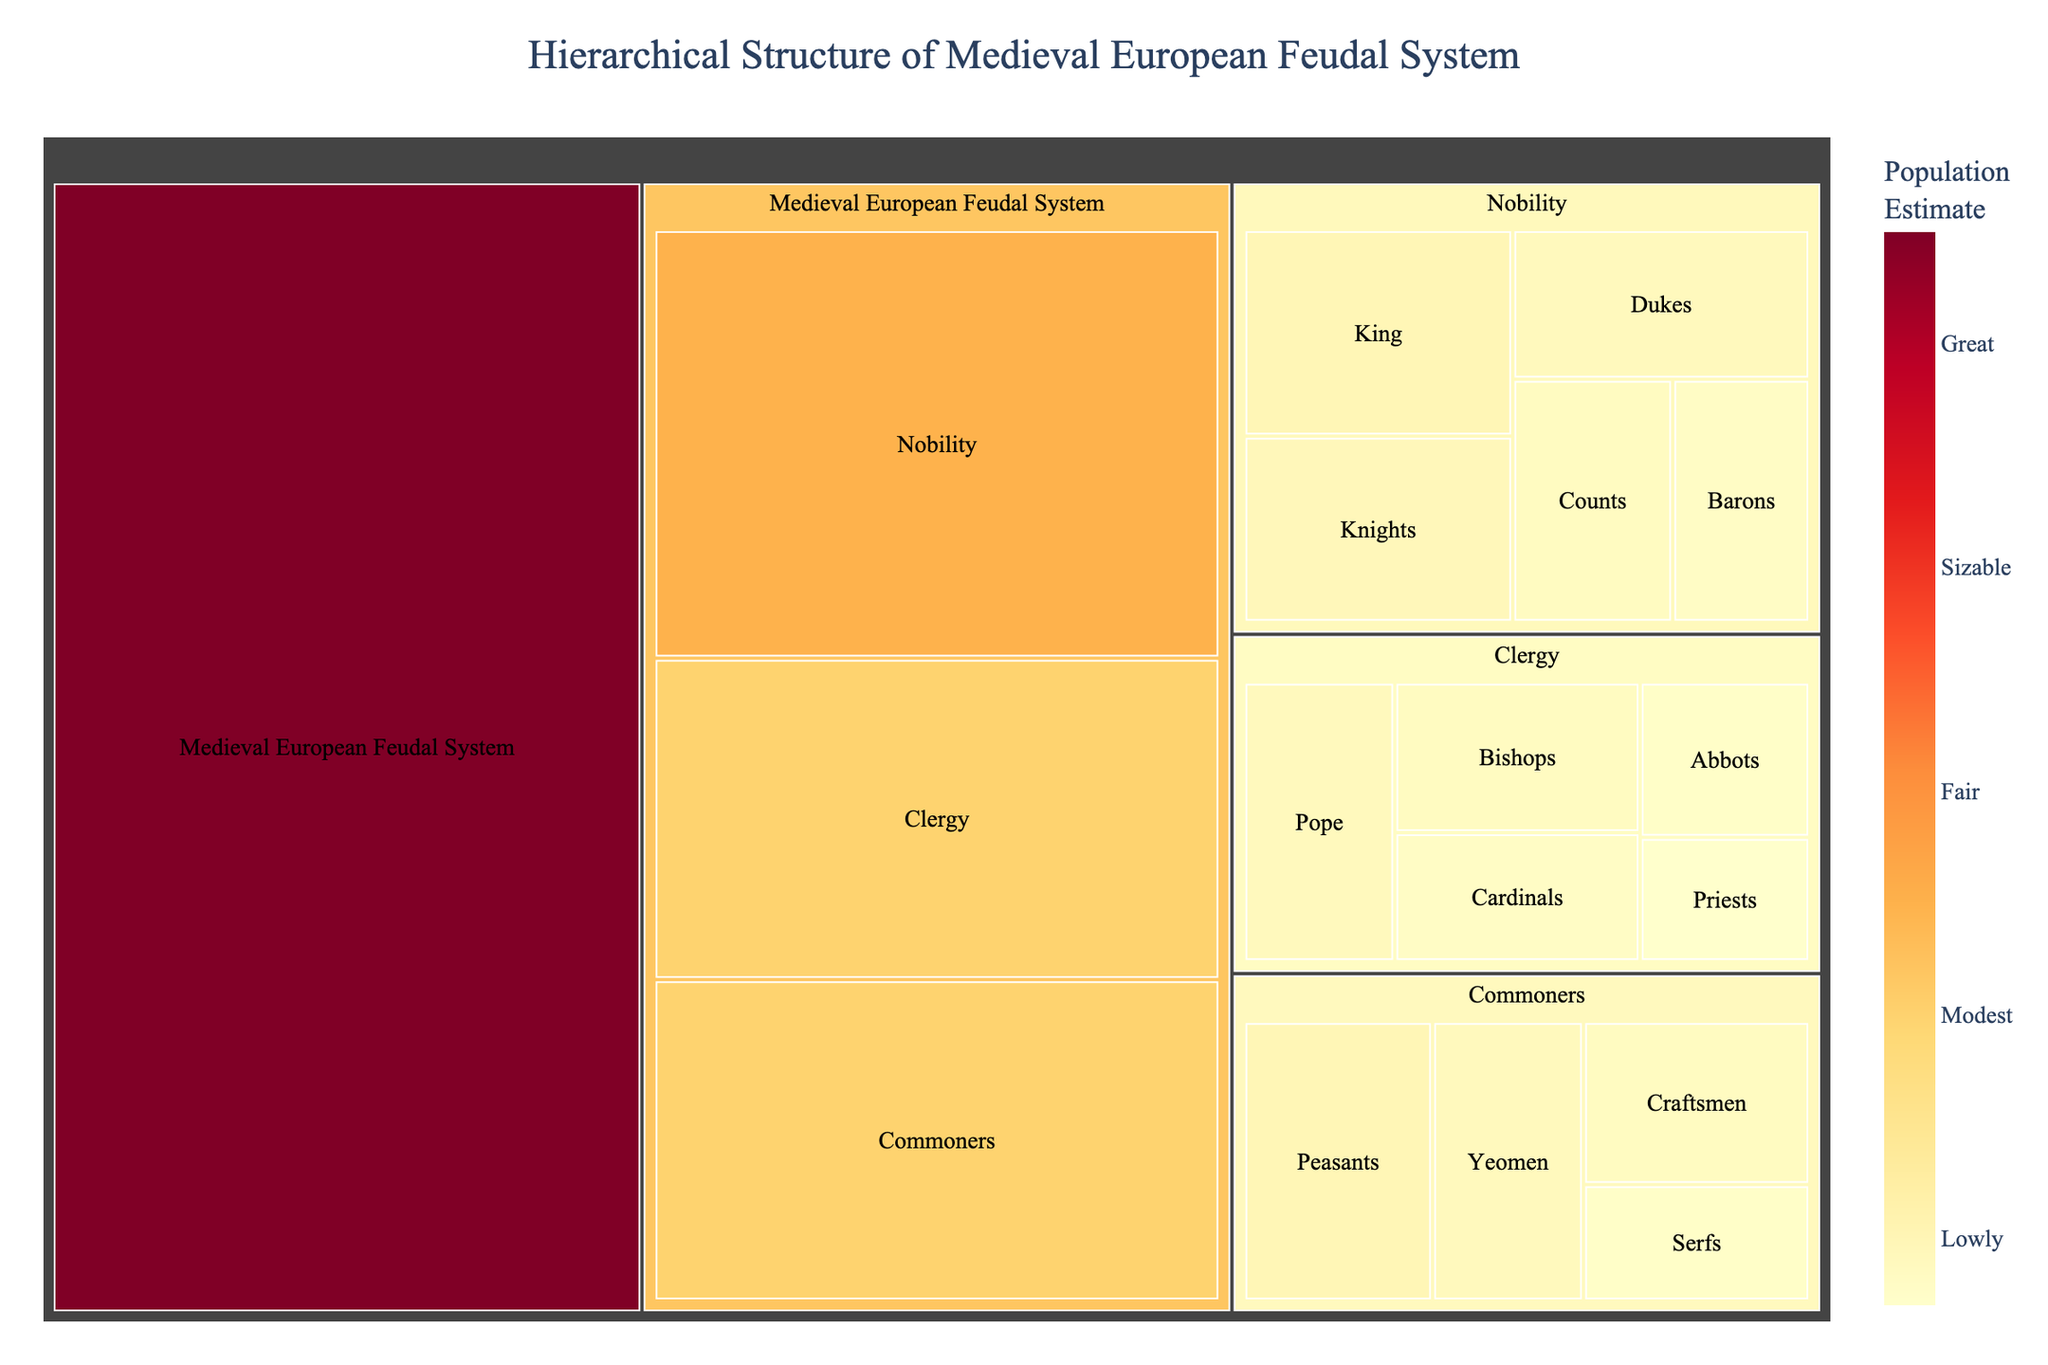How many hierarchical groups are represented in the treemap? The treemap displays three primary groups under the medieval European feudal system: Nobility, Clergy, and Commoners.
Answer: 3 Which subgroup under Nobility has the largest population estimate? Within the Nobility group, the King has the highest population estimate, which is 100.
Answer: King What is the total population estimate for the Clergy group? The population estimates for the Clergy group are: Pope (80), Cardinals (60), Bishops (70), Abbots (50), and Priests (40). Summing them up gives 80 + 60 + 70 + 50 + 40 = 300.
Answer: 300 Compare the population estimates of Yeomen and Serfs. Which is higher? The population estimate for Yeomen is 80, whereas for Serfs it is 50. Yeomen have a higher population estimate.
Answer: Yeomen What is the average population estimate for subgroups under Commoners? The subgroups under Commoners are Yeomen, Craftsmen, Peasants, and Serfs, with population estimates of 80, 70, 100, and 50, respectively. Summing these gives 80 + 70 + 100 + 50 = 300. The average is 300/4 = 75.
Answer: 75 Which has a greater population estimate: Bishops or Counts? The population estimate for Bishops is 70, and for Counts, it is also 70. They are equal.
Answer: Equal What is the title of the treemap? The title of the treemap is displayed at the top center and reads "Hierarchical Structure of Medieval European Feudal System".
Answer: Hierarchical Structure of Medieval European Feudal System Of the primary groups, which one has the largest population estimate? The three primary groups are Nobility, Clergy, and Commoners, with estimates of 400, 300, and 300, respectively. Nobility has the largest estimate at 400.
Answer: Nobility What is the combined population estimate of Dukes and Barons? The population estimates for Dukes and Barons are 80 and 60, respectively. Their combined estimate is 80 + 60 = 140.
Answer: 140 